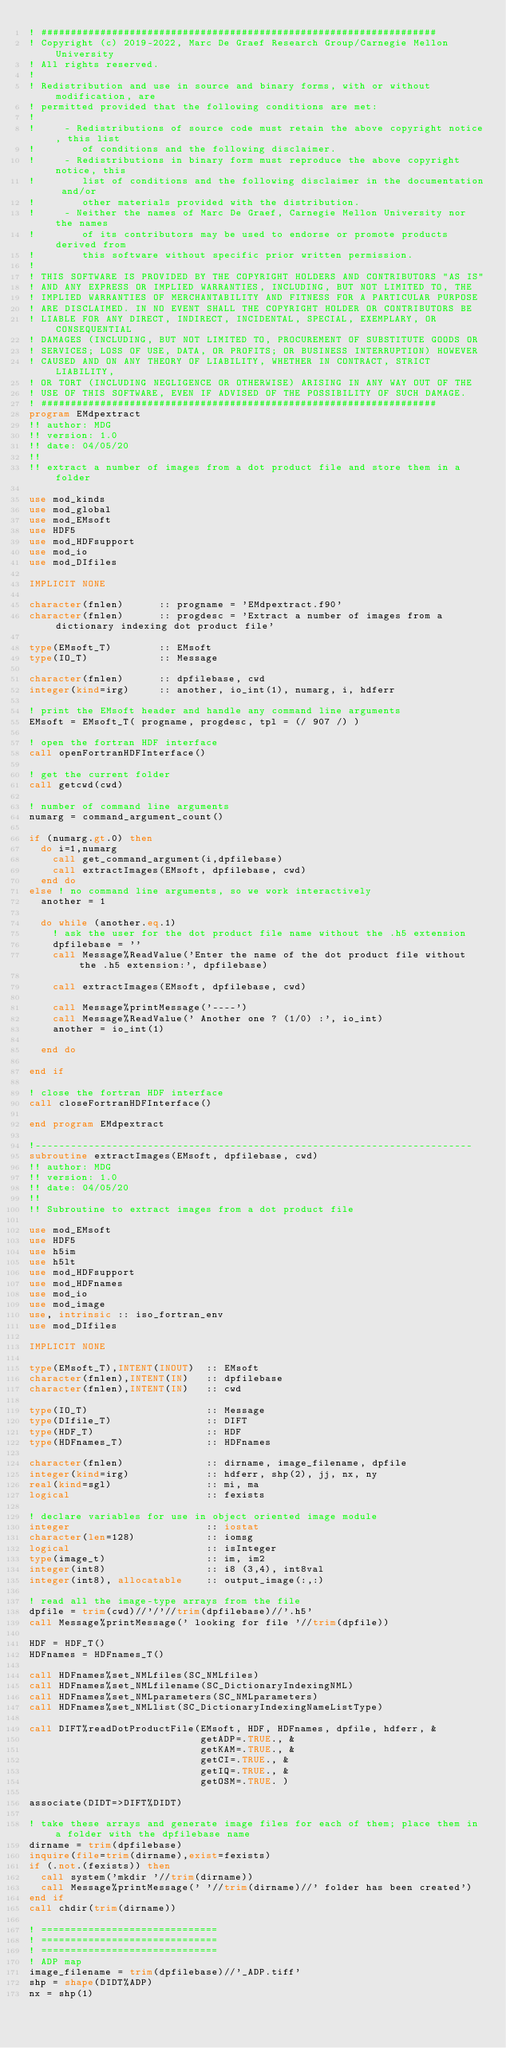Convert code to text. <code><loc_0><loc_0><loc_500><loc_500><_FORTRAN_>! ###################################################################
! Copyright (c) 2019-2022, Marc De Graef Research Group/Carnegie Mellon University
! All rights reserved.
!
! Redistribution and use in source and binary forms, with or without modification, are
! permitted provided that the following conditions are met:
!
!     - Redistributions of source code must retain the above copyright notice, this list
!        of conditions and the following disclaimer.
!     - Redistributions in binary form must reproduce the above copyright notice, this
!        list of conditions and the following disclaimer in the documentation and/or
!        other materials provided with the distribution.
!     - Neither the names of Marc De Graef, Carnegie Mellon University nor the names
!        of its contributors may be used to endorse or promote products derived from
!        this software without specific prior written permission.
!
! THIS SOFTWARE IS PROVIDED BY THE COPYRIGHT HOLDERS AND CONTRIBUTORS "AS IS"
! AND ANY EXPRESS OR IMPLIED WARRANTIES, INCLUDING, BUT NOT LIMITED TO, THE
! IMPLIED WARRANTIES OF MERCHANTABILITY AND FITNESS FOR A PARTICULAR PURPOSE
! ARE DISCLAIMED. IN NO EVENT SHALL THE COPYRIGHT HOLDER OR CONTRIBUTORS BE
! LIABLE FOR ANY DIRECT, INDIRECT, INCIDENTAL, SPECIAL, EXEMPLARY, OR CONSEQUENTIAL
! DAMAGES (INCLUDING, BUT NOT LIMITED TO, PROCUREMENT OF SUBSTITUTE GOODS OR
! SERVICES; LOSS OF USE, DATA, OR PROFITS; OR BUSINESS INTERRUPTION) HOWEVER
! CAUSED AND ON ANY THEORY OF LIABILITY, WHETHER IN CONTRACT, STRICT LIABILITY,
! OR TORT (INCLUDING NEGLIGENCE OR OTHERWISE) ARISING IN ANY WAY OUT OF THE
! USE OF THIS SOFTWARE, EVEN IF ADVISED OF THE POSSIBILITY OF SUCH DAMAGE.
! ###################################################################
program EMdpextract
!! author: MDG 
!! version: 1.0 
!! date: 04/05/20
!!
!! extract a number of images from a dot product file and store them in a folder

use mod_kinds 
use mod_global
use mod_EMsoft
use HDF5
use mod_HDFsupport
use mod_io
use mod_DIfiles

IMPLICIT NONE

character(fnlen)      :: progname = 'EMdpextract.f90' 
character(fnlen)      :: progdesc = 'Extract a number of images from a dictionary indexing dot product file'

type(EMsoft_T)        :: EMsoft 
type(IO_T)            :: Message 

character(fnlen)      :: dpfilebase, cwd
integer(kind=irg)     :: another, io_int(1), numarg, i, hdferr

! print the EMsoft header and handle any command line arguments  
EMsoft = EMsoft_T( progname, progdesc, tpl = (/ 907 /) )

! open the fortran HDF interface
call openFortranHDFInterface()

! get the current folder 
call getcwd(cwd)

! number of command line arguments
numarg = command_argument_count()

if (numarg.gt.0) then
  do i=1,numarg
    call get_command_argument(i,dpfilebase)
    call extractImages(EMsoft, dpfilebase, cwd)
  end do
else ! no command line arguments, so we work interactively 
  another = 1

  do while (another.eq.1) 
    ! ask the user for the dot product file name without the .h5 extension
    dpfilebase = ''
    call Message%ReadValue('Enter the name of the dot product file without the .h5 extension:', dpfilebase)

    call extractImages(EMsoft, dpfilebase, cwd)

    call Message%printMessage('----')
    call Message%ReadValue(' Another one ? (1/0) :', io_int)
    another = io_int(1)

  end do 

end if

! close the fortran HDF interface
call closeFortranHDFInterface()

end program EMdpextract

!--------------------------------------------------------------------------
subroutine extractImages(EMsoft, dpfilebase, cwd)
!! author: MDG 
!! version: 1.0 
!! date: 04/05/20
!!
!! Subroutine to extract images from a dot product file

use mod_EMsoft
use HDF5
use h5im
use h5lt
use mod_HDFsupport
use mod_HDFnames
use mod_io
use mod_image
use, intrinsic :: iso_fortran_env
use mod_DIfiles

IMPLICIT NONE 

type(EMsoft_T),INTENT(INOUT)  :: EMsoft
character(fnlen),INTENT(IN)   :: dpfilebase 
character(fnlen),INTENT(IN)   :: cwd

type(IO_T)                    :: Message
type(DIfile_T)                :: DIFT 
type(HDF_T)                   :: HDF 
type(HDFnames_T)              :: HDFnames

character(fnlen)              :: dirname, image_filename, dpfile
integer(kind=irg)             :: hdferr, shp(2), jj, nx, ny
real(kind=sgl)                :: mi, ma
logical                       :: fexists

! declare variables for use in object oriented image module
integer                       :: iostat
character(len=128)            :: iomsg
logical                       :: isInteger
type(image_t)                 :: im, im2
integer(int8)                 :: i8 (3,4), int8val
integer(int8), allocatable    :: output_image(:,:)

! read all the image-type arrays from the file
dpfile = trim(cwd)//'/'//trim(dpfilebase)//'.h5'
call Message%printMessage(' looking for file '//trim(dpfile))

HDF = HDF_T() 
HDFnames = HDFnames_T() 

call HDFnames%set_NMLfiles(SC_NMLfiles)
call HDFnames%set_NMLfilename(SC_DictionaryIndexingNML)
call HDFnames%set_NMLparameters(SC_NMLparameters)
call HDFnames%set_NMLlist(SC_DictionaryIndexingNameListType)

call DIFT%readDotProductFile(EMsoft, HDF, HDFnames, dpfile, hdferr, &
                             getADP=.TRUE., &
                             getKAM=.TRUE., &
                             getCI=.TRUE., &
                             getIQ=.TRUE., & 
                             getOSM=.TRUE. )

associate(DIDT=>DIFT%DIDT)

! take these arrays and generate image files for each of them; place them in a folder with the dpfilebase name 
dirname = trim(dpfilebase)
inquire(file=trim(dirname),exist=fexists)
if (.not.(fexists)) then
  call system('mkdir '//trim(dirname))
  call Message%printMessage(' '//trim(dirname)//' folder has been created')
end if
call chdir(trim(dirname))

! ==============================
! ==============================
! ==============================
! ADP map
image_filename = trim(dpfilebase)//'_ADP.tiff'
shp = shape(DIDT%ADP)
nx = shp(1)</code> 